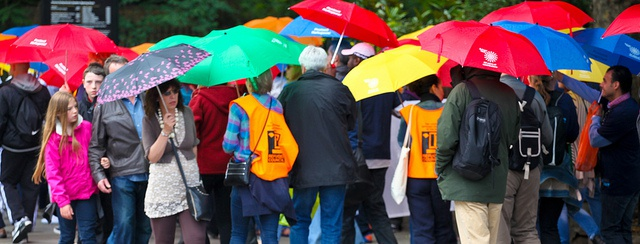Describe the objects in this image and their specific colors. I can see people in black, maroon, navy, and gray tones, people in black, gray, and beige tones, people in black, navy, and blue tones, people in black, navy, orange, and red tones, and people in black, gray, lightgray, and darkgray tones in this image. 